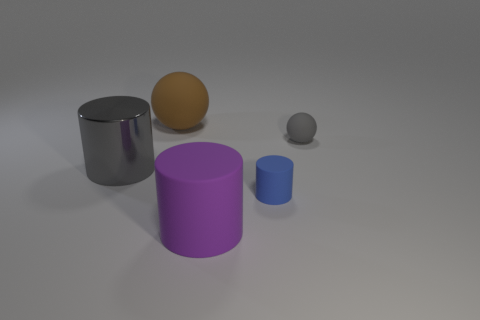Is there a rubber object that has the same color as the metal cylinder?
Give a very brief answer. Yes. What is the shape of the big shiny object that is the same color as the small sphere?
Give a very brief answer. Cylinder. Does the big shiny cylinder have the same color as the tiny rubber sphere?
Offer a very short reply. Yes. Does the rubber sphere that is to the right of the large purple rubber object have the same color as the large metallic cylinder?
Give a very brief answer. Yes. Are there any other things that have the same color as the shiny cylinder?
Make the answer very short. Yes. Is the size of the purple rubber thing the same as the gray metal cylinder?
Make the answer very short. Yes. There is another large object that is the same shape as the large gray thing; what is it made of?
Make the answer very short. Rubber. Are there any other things that have the same material as the big brown ball?
Give a very brief answer. Yes. What number of cyan objects are cylinders or big objects?
Offer a very short reply. 0. There is a big thing that is behind the large shiny object; what material is it?
Provide a succinct answer. Rubber. 